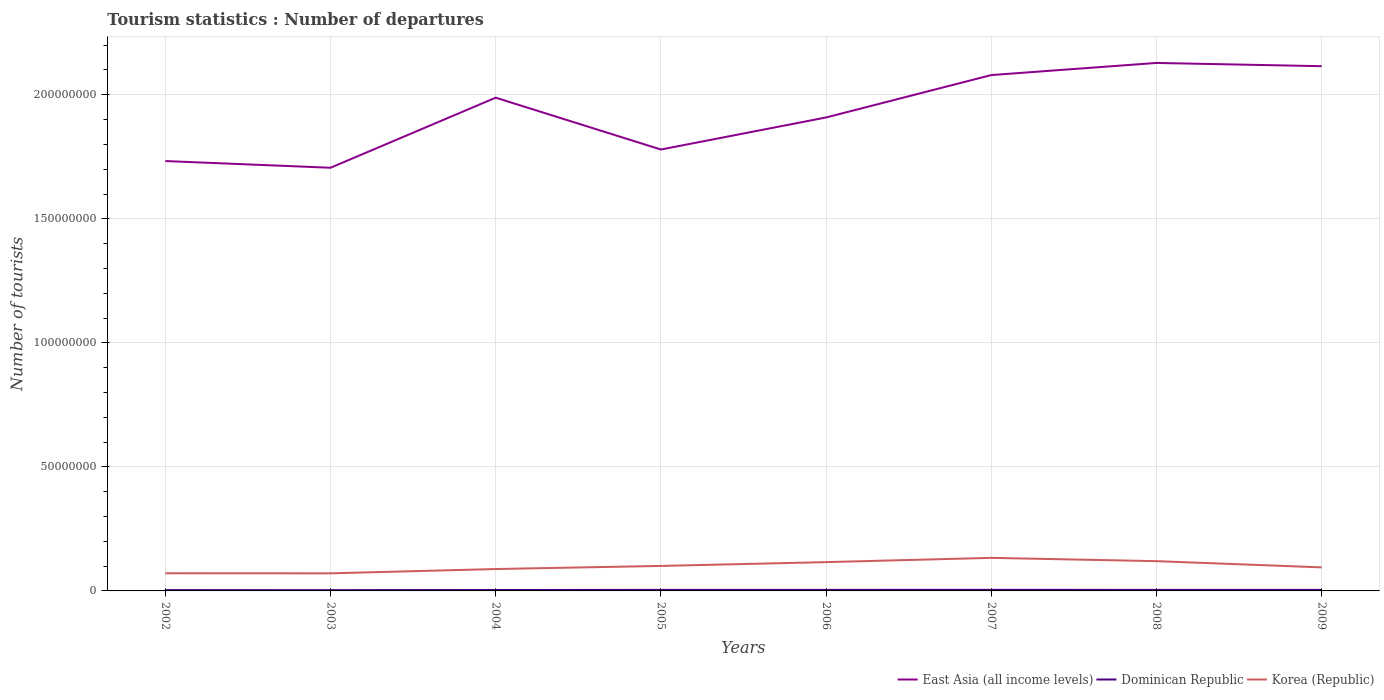Does the line corresponding to Dominican Republic intersect with the line corresponding to East Asia (all income levels)?
Offer a terse response. No. Is the number of lines equal to the number of legend labels?
Your answer should be compact. Yes. Across all years, what is the maximum number of tourist departures in Dominican Republic?
Offer a terse response. 3.21e+05. What is the total number of tourist departures in Dominican Republic in the graph?
Offer a very short reply. 2.80e+04. What is the difference between the highest and the second highest number of tourist departures in East Asia (all income levels)?
Provide a succinct answer. 4.23e+07. What is the difference between the highest and the lowest number of tourist departures in East Asia (all income levels)?
Offer a very short reply. 4. Is the number of tourist departures in East Asia (all income levels) strictly greater than the number of tourist departures in Dominican Republic over the years?
Give a very brief answer. No. How many lines are there?
Offer a terse response. 3. What is the difference between two consecutive major ticks on the Y-axis?
Your answer should be compact. 5.00e+07. Does the graph contain any zero values?
Keep it short and to the point. No. What is the title of the graph?
Offer a terse response. Tourism statistics : Number of departures. What is the label or title of the X-axis?
Your response must be concise. Years. What is the label or title of the Y-axis?
Provide a short and direct response. Number of tourists. What is the Number of tourists of East Asia (all income levels) in 2002?
Make the answer very short. 1.73e+08. What is the Number of tourists in Dominican Republic in 2002?
Your answer should be compact. 3.32e+05. What is the Number of tourists in Korea (Republic) in 2002?
Keep it short and to the point. 7.12e+06. What is the Number of tourists of East Asia (all income levels) in 2003?
Make the answer very short. 1.71e+08. What is the Number of tourists of Dominican Republic in 2003?
Give a very brief answer. 3.21e+05. What is the Number of tourists in Korea (Republic) in 2003?
Your answer should be very brief. 7.09e+06. What is the Number of tourists of East Asia (all income levels) in 2004?
Give a very brief answer. 1.99e+08. What is the Number of tourists in Dominican Republic in 2004?
Provide a short and direct response. 3.68e+05. What is the Number of tourists in Korea (Republic) in 2004?
Keep it short and to the point. 8.83e+06. What is the Number of tourists in East Asia (all income levels) in 2005?
Your answer should be very brief. 1.78e+08. What is the Number of tourists of Dominican Republic in 2005?
Ensure brevity in your answer.  4.19e+05. What is the Number of tourists in Korea (Republic) in 2005?
Your answer should be compact. 1.01e+07. What is the Number of tourists of East Asia (all income levels) in 2006?
Your answer should be compact. 1.91e+08. What is the Number of tourists of Dominican Republic in 2006?
Provide a short and direct response. 4.20e+05. What is the Number of tourists of Korea (Republic) in 2006?
Provide a succinct answer. 1.16e+07. What is the Number of tourists in East Asia (all income levels) in 2007?
Your answer should be very brief. 2.08e+08. What is the Number of tourists in Dominican Republic in 2007?
Provide a short and direct response. 4.43e+05. What is the Number of tourists of Korea (Republic) in 2007?
Ensure brevity in your answer.  1.33e+07. What is the Number of tourists in East Asia (all income levels) in 2008?
Give a very brief answer. 2.13e+08. What is the Number of tourists in Dominican Republic in 2008?
Your answer should be very brief. 4.13e+05. What is the Number of tourists of Korea (Republic) in 2008?
Offer a very short reply. 1.20e+07. What is the Number of tourists of East Asia (all income levels) in 2009?
Offer a very short reply. 2.12e+08. What is the Number of tourists of Dominican Republic in 2009?
Give a very brief answer. 4.15e+05. What is the Number of tourists of Korea (Republic) in 2009?
Ensure brevity in your answer.  9.49e+06. Across all years, what is the maximum Number of tourists of East Asia (all income levels)?
Your answer should be very brief. 2.13e+08. Across all years, what is the maximum Number of tourists in Dominican Republic?
Keep it short and to the point. 4.43e+05. Across all years, what is the maximum Number of tourists in Korea (Republic)?
Your answer should be very brief. 1.33e+07. Across all years, what is the minimum Number of tourists of East Asia (all income levels)?
Offer a terse response. 1.71e+08. Across all years, what is the minimum Number of tourists in Dominican Republic?
Your response must be concise. 3.21e+05. Across all years, what is the minimum Number of tourists of Korea (Republic)?
Your answer should be very brief. 7.09e+06. What is the total Number of tourists in East Asia (all income levels) in the graph?
Keep it short and to the point. 1.54e+09. What is the total Number of tourists in Dominican Republic in the graph?
Offer a very short reply. 3.13e+06. What is the total Number of tourists in Korea (Republic) in the graph?
Give a very brief answer. 7.95e+07. What is the difference between the Number of tourists in East Asia (all income levels) in 2002 and that in 2003?
Offer a very short reply. 2.70e+06. What is the difference between the Number of tourists in Dominican Republic in 2002 and that in 2003?
Your response must be concise. 1.10e+04. What is the difference between the Number of tourists in Korea (Republic) in 2002 and that in 2003?
Offer a very short reply. 3.70e+04. What is the difference between the Number of tourists of East Asia (all income levels) in 2002 and that in 2004?
Provide a short and direct response. -2.56e+07. What is the difference between the Number of tourists of Dominican Republic in 2002 and that in 2004?
Offer a very short reply. -3.60e+04. What is the difference between the Number of tourists of Korea (Republic) in 2002 and that in 2004?
Your answer should be compact. -1.70e+06. What is the difference between the Number of tourists of East Asia (all income levels) in 2002 and that in 2005?
Give a very brief answer. -4.65e+06. What is the difference between the Number of tourists in Dominican Republic in 2002 and that in 2005?
Ensure brevity in your answer.  -8.70e+04. What is the difference between the Number of tourists of Korea (Republic) in 2002 and that in 2005?
Keep it short and to the point. -2.96e+06. What is the difference between the Number of tourists in East Asia (all income levels) in 2002 and that in 2006?
Give a very brief answer. -1.76e+07. What is the difference between the Number of tourists of Dominican Republic in 2002 and that in 2006?
Offer a terse response. -8.80e+04. What is the difference between the Number of tourists in Korea (Republic) in 2002 and that in 2006?
Your response must be concise. -4.49e+06. What is the difference between the Number of tourists in East Asia (all income levels) in 2002 and that in 2007?
Provide a succinct answer. -3.47e+07. What is the difference between the Number of tourists in Dominican Republic in 2002 and that in 2007?
Provide a short and direct response. -1.11e+05. What is the difference between the Number of tourists in Korea (Republic) in 2002 and that in 2007?
Your answer should be very brief. -6.20e+06. What is the difference between the Number of tourists in East Asia (all income levels) in 2002 and that in 2008?
Provide a succinct answer. -3.96e+07. What is the difference between the Number of tourists of Dominican Republic in 2002 and that in 2008?
Keep it short and to the point. -8.10e+04. What is the difference between the Number of tourists in Korea (Republic) in 2002 and that in 2008?
Your answer should be compact. -4.87e+06. What is the difference between the Number of tourists of East Asia (all income levels) in 2002 and that in 2009?
Your response must be concise. -3.82e+07. What is the difference between the Number of tourists of Dominican Republic in 2002 and that in 2009?
Keep it short and to the point. -8.30e+04. What is the difference between the Number of tourists in Korea (Republic) in 2002 and that in 2009?
Make the answer very short. -2.37e+06. What is the difference between the Number of tourists of East Asia (all income levels) in 2003 and that in 2004?
Provide a short and direct response. -2.82e+07. What is the difference between the Number of tourists in Dominican Republic in 2003 and that in 2004?
Give a very brief answer. -4.70e+04. What is the difference between the Number of tourists in Korea (Republic) in 2003 and that in 2004?
Your answer should be very brief. -1.74e+06. What is the difference between the Number of tourists in East Asia (all income levels) in 2003 and that in 2005?
Your answer should be compact. -7.35e+06. What is the difference between the Number of tourists in Dominican Republic in 2003 and that in 2005?
Keep it short and to the point. -9.80e+04. What is the difference between the Number of tourists of Korea (Republic) in 2003 and that in 2005?
Offer a very short reply. -2.99e+06. What is the difference between the Number of tourists in East Asia (all income levels) in 2003 and that in 2006?
Offer a very short reply. -2.03e+07. What is the difference between the Number of tourists of Dominican Republic in 2003 and that in 2006?
Give a very brief answer. -9.90e+04. What is the difference between the Number of tourists in Korea (Republic) in 2003 and that in 2006?
Keep it short and to the point. -4.52e+06. What is the difference between the Number of tourists of East Asia (all income levels) in 2003 and that in 2007?
Your answer should be very brief. -3.74e+07. What is the difference between the Number of tourists in Dominican Republic in 2003 and that in 2007?
Your answer should be compact. -1.22e+05. What is the difference between the Number of tourists in Korea (Republic) in 2003 and that in 2007?
Your answer should be very brief. -6.24e+06. What is the difference between the Number of tourists of East Asia (all income levels) in 2003 and that in 2008?
Your answer should be very brief. -4.23e+07. What is the difference between the Number of tourists of Dominican Republic in 2003 and that in 2008?
Give a very brief answer. -9.20e+04. What is the difference between the Number of tourists in Korea (Republic) in 2003 and that in 2008?
Your response must be concise. -4.91e+06. What is the difference between the Number of tourists in East Asia (all income levels) in 2003 and that in 2009?
Offer a terse response. -4.09e+07. What is the difference between the Number of tourists of Dominican Republic in 2003 and that in 2009?
Your answer should be compact. -9.40e+04. What is the difference between the Number of tourists in Korea (Republic) in 2003 and that in 2009?
Keep it short and to the point. -2.41e+06. What is the difference between the Number of tourists of East Asia (all income levels) in 2004 and that in 2005?
Make the answer very short. 2.09e+07. What is the difference between the Number of tourists of Dominican Republic in 2004 and that in 2005?
Make the answer very short. -5.10e+04. What is the difference between the Number of tourists in Korea (Republic) in 2004 and that in 2005?
Provide a short and direct response. -1.25e+06. What is the difference between the Number of tourists in East Asia (all income levels) in 2004 and that in 2006?
Your answer should be very brief. 7.97e+06. What is the difference between the Number of tourists in Dominican Republic in 2004 and that in 2006?
Offer a terse response. -5.20e+04. What is the difference between the Number of tourists of Korea (Republic) in 2004 and that in 2006?
Provide a succinct answer. -2.78e+06. What is the difference between the Number of tourists of East Asia (all income levels) in 2004 and that in 2007?
Offer a very short reply. -9.12e+06. What is the difference between the Number of tourists of Dominican Republic in 2004 and that in 2007?
Your answer should be very brief. -7.50e+04. What is the difference between the Number of tourists of Korea (Republic) in 2004 and that in 2007?
Make the answer very short. -4.50e+06. What is the difference between the Number of tourists of East Asia (all income levels) in 2004 and that in 2008?
Your response must be concise. -1.40e+07. What is the difference between the Number of tourists in Dominican Republic in 2004 and that in 2008?
Make the answer very short. -4.50e+04. What is the difference between the Number of tourists of Korea (Republic) in 2004 and that in 2008?
Your response must be concise. -3.17e+06. What is the difference between the Number of tourists in East Asia (all income levels) in 2004 and that in 2009?
Provide a succinct answer. -1.27e+07. What is the difference between the Number of tourists of Dominican Republic in 2004 and that in 2009?
Ensure brevity in your answer.  -4.70e+04. What is the difference between the Number of tourists in Korea (Republic) in 2004 and that in 2009?
Make the answer very short. -6.68e+05. What is the difference between the Number of tourists of East Asia (all income levels) in 2005 and that in 2006?
Give a very brief answer. -1.29e+07. What is the difference between the Number of tourists in Dominican Republic in 2005 and that in 2006?
Your answer should be compact. -1000. What is the difference between the Number of tourists of Korea (Republic) in 2005 and that in 2006?
Make the answer very short. -1.53e+06. What is the difference between the Number of tourists of East Asia (all income levels) in 2005 and that in 2007?
Provide a succinct answer. -3.00e+07. What is the difference between the Number of tourists in Dominican Republic in 2005 and that in 2007?
Your answer should be very brief. -2.40e+04. What is the difference between the Number of tourists in Korea (Republic) in 2005 and that in 2007?
Your response must be concise. -3.24e+06. What is the difference between the Number of tourists of East Asia (all income levels) in 2005 and that in 2008?
Your response must be concise. -3.49e+07. What is the difference between the Number of tourists in Dominican Republic in 2005 and that in 2008?
Give a very brief answer. 6000. What is the difference between the Number of tourists of Korea (Republic) in 2005 and that in 2008?
Make the answer very short. -1.92e+06. What is the difference between the Number of tourists in East Asia (all income levels) in 2005 and that in 2009?
Provide a succinct answer. -3.36e+07. What is the difference between the Number of tourists of Dominican Republic in 2005 and that in 2009?
Your answer should be very brief. 4000. What is the difference between the Number of tourists of Korea (Republic) in 2005 and that in 2009?
Provide a short and direct response. 5.86e+05. What is the difference between the Number of tourists of East Asia (all income levels) in 2006 and that in 2007?
Ensure brevity in your answer.  -1.71e+07. What is the difference between the Number of tourists in Dominican Republic in 2006 and that in 2007?
Your answer should be very brief. -2.30e+04. What is the difference between the Number of tourists of Korea (Republic) in 2006 and that in 2007?
Offer a very short reply. -1.72e+06. What is the difference between the Number of tourists of East Asia (all income levels) in 2006 and that in 2008?
Ensure brevity in your answer.  -2.20e+07. What is the difference between the Number of tourists of Dominican Republic in 2006 and that in 2008?
Make the answer very short. 7000. What is the difference between the Number of tourists of Korea (Republic) in 2006 and that in 2008?
Offer a very short reply. -3.86e+05. What is the difference between the Number of tourists in East Asia (all income levels) in 2006 and that in 2009?
Your answer should be very brief. -2.07e+07. What is the difference between the Number of tourists in Dominican Republic in 2006 and that in 2009?
Keep it short and to the point. 5000. What is the difference between the Number of tourists in Korea (Republic) in 2006 and that in 2009?
Your response must be concise. 2.12e+06. What is the difference between the Number of tourists in East Asia (all income levels) in 2007 and that in 2008?
Make the answer very short. -4.89e+06. What is the difference between the Number of tourists in Dominican Republic in 2007 and that in 2008?
Keep it short and to the point. 3.00e+04. What is the difference between the Number of tourists of Korea (Republic) in 2007 and that in 2008?
Keep it short and to the point. 1.33e+06. What is the difference between the Number of tourists of East Asia (all income levels) in 2007 and that in 2009?
Provide a succinct answer. -3.58e+06. What is the difference between the Number of tourists in Dominican Republic in 2007 and that in 2009?
Offer a very short reply. 2.80e+04. What is the difference between the Number of tourists in Korea (Republic) in 2007 and that in 2009?
Give a very brief answer. 3.83e+06. What is the difference between the Number of tourists in East Asia (all income levels) in 2008 and that in 2009?
Provide a succinct answer. 1.31e+06. What is the difference between the Number of tourists of Dominican Republic in 2008 and that in 2009?
Provide a short and direct response. -2000. What is the difference between the Number of tourists of Korea (Republic) in 2008 and that in 2009?
Ensure brevity in your answer.  2.50e+06. What is the difference between the Number of tourists of East Asia (all income levels) in 2002 and the Number of tourists of Dominican Republic in 2003?
Ensure brevity in your answer.  1.73e+08. What is the difference between the Number of tourists of East Asia (all income levels) in 2002 and the Number of tourists of Korea (Republic) in 2003?
Provide a succinct answer. 1.66e+08. What is the difference between the Number of tourists in Dominican Republic in 2002 and the Number of tourists in Korea (Republic) in 2003?
Provide a short and direct response. -6.75e+06. What is the difference between the Number of tourists of East Asia (all income levels) in 2002 and the Number of tourists of Dominican Republic in 2004?
Your answer should be compact. 1.73e+08. What is the difference between the Number of tourists in East Asia (all income levels) in 2002 and the Number of tourists in Korea (Republic) in 2004?
Give a very brief answer. 1.64e+08. What is the difference between the Number of tourists in Dominican Republic in 2002 and the Number of tourists in Korea (Republic) in 2004?
Your answer should be compact. -8.49e+06. What is the difference between the Number of tourists of East Asia (all income levels) in 2002 and the Number of tourists of Dominican Republic in 2005?
Your answer should be compact. 1.73e+08. What is the difference between the Number of tourists in East Asia (all income levels) in 2002 and the Number of tourists in Korea (Republic) in 2005?
Your answer should be very brief. 1.63e+08. What is the difference between the Number of tourists in Dominican Republic in 2002 and the Number of tourists in Korea (Republic) in 2005?
Your answer should be compact. -9.75e+06. What is the difference between the Number of tourists in East Asia (all income levels) in 2002 and the Number of tourists in Dominican Republic in 2006?
Keep it short and to the point. 1.73e+08. What is the difference between the Number of tourists of East Asia (all income levels) in 2002 and the Number of tourists of Korea (Republic) in 2006?
Your answer should be very brief. 1.62e+08. What is the difference between the Number of tourists in Dominican Republic in 2002 and the Number of tourists in Korea (Republic) in 2006?
Make the answer very short. -1.13e+07. What is the difference between the Number of tourists in East Asia (all income levels) in 2002 and the Number of tourists in Dominican Republic in 2007?
Ensure brevity in your answer.  1.73e+08. What is the difference between the Number of tourists of East Asia (all income levels) in 2002 and the Number of tourists of Korea (Republic) in 2007?
Your response must be concise. 1.60e+08. What is the difference between the Number of tourists in Dominican Republic in 2002 and the Number of tourists in Korea (Republic) in 2007?
Make the answer very short. -1.30e+07. What is the difference between the Number of tourists in East Asia (all income levels) in 2002 and the Number of tourists in Dominican Republic in 2008?
Your answer should be very brief. 1.73e+08. What is the difference between the Number of tourists of East Asia (all income levels) in 2002 and the Number of tourists of Korea (Republic) in 2008?
Keep it short and to the point. 1.61e+08. What is the difference between the Number of tourists of Dominican Republic in 2002 and the Number of tourists of Korea (Republic) in 2008?
Offer a terse response. -1.17e+07. What is the difference between the Number of tourists of East Asia (all income levels) in 2002 and the Number of tourists of Dominican Republic in 2009?
Keep it short and to the point. 1.73e+08. What is the difference between the Number of tourists of East Asia (all income levels) in 2002 and the Number of tourists of Korea (Republic) in 2009?
Provide a short and direct response. 1.64e+08. What is the difference between the Number of tourists in Dominican Republic in 2002 and the Number of tourists in Korea (Republic) in 2009?
Provide a succinct answer. -9.16e+06. What is the difference between the Number of tourists of East Asia (all income levels) in 2003 and the Number of tourists of Dominican Republic in 2004?
Provide a succinct answer. 1.70e+08. What is the difference between the Number of tourists in East Asia (all income levels) in 2003 and the Number of tourists in Korea (Republic) in 2004?
Provide a short and direct response. 1.62e+08. What is the difference between the Number of tourists in Dominican Republic in 2003 and the Number of tourists in Korea (Republic) in 2004?
Make the answer very short. -8.50e+06. What is the difference between the Number of tourists in East Asia (all income levels) in 2003 and the Number of tourists in Dominican Republic in 2005?
Provide a succinct answer. 1.70e+08. What is the difference between the Number of tourists in East Asia (all income levels) in 2003 and the Number of tourists in Korea (Republic) in 2005?
Give a very brief answer. 1.61e+08. What is the difference between the Number of tourists in Dominican Republic in 2003 and the Number of tourists in Korea (Republic) in 2005?
Offer a very short reply. -9.76e+06. What is the difference between the Number of tourists of East Asia (all income levels) in 2003 and the Number of tourists of Dominican Republic in 2006?
Give a very brief answer. 1.70e+08. What is the difference between the Number of tourists of East Asia (all income levels) in 2003 and the Number of tourists of Korea (Republic) in 2006?
Ensure brevity in your answer.  1.59e+08. What is the difference between the Number of tourists of Dominican Republic in 2003 and the Number of tourists of Korea (Republic) in 2006?
Offer a very short reply. -1.13e+07. What is the difference between the Number of tourists in East Asia (all income levels) in 2003 and the Number of tourists in Dominican Republic in 2007?
Your answer should be compact. 1.70e+08. What is the difference between the Number of tourists in East Asia (all income levels) in 2003 and the Number of tourists in Korea (Republic) in 2007?
Your response must be concise. 1.57e+08. What is the difference between the Number of tourists of Dominican Republic in 2003 and the Number of tourists of Korea (Republic) in 2007?
Offer a very short reply. -1.30e+07. What is the difference between the Number of tourists of East Asia (all income levels) in 2003 and the Number of tourists of Dominican Republic in 2008?
Keep it short and to the point. 1.70e+08. What is the difference between the Number of tourists in East Asia (all income levels) in 2003 and the Number of tourists in Korea (Republic) in 2008?
Make the answer very short. 1.59e+08. What is the difference between the Number of tourists in Dominican Republic in 2003 and the Number of tourists in Korea (Republic) in 2008?
Give a very brief answer. -1.17e+07. What is the difference between the Number of tourists of East Asia (all income levels) in 2003 and the Number of tourists of Dominican Republic in 2009?
Ensure brevity in your answer.  1.70e+08. What is the difference between the Number of tourists of East Asia (all income levels) in 2003 and the Number of tourists of Korea (Republic) in 2009?
Your answer should be very brief. 1.61e+08. What is the difference between the Number of tourists of Dominican Republic in 2003 and the Number of tourists of Korea (Republic) in 2009?
Give a very brief answer. -9.17e+06. What is the difference between the Number of tourists of East Asia (all income levels) in 2004 and the Number of tourists of Dominican Republic in 2005?
Keep it short and to the point. 1.98e+08. What is the difference between the Number of tourists in East Asia (all income levels) in 2004 and the Number of tourists in Korea (Republic) in 2005?
Your answer should be very brief. 1.89e+08. What is the difference between the Number of tourists in Dominican Republic in 2004 and the Number of tourists in Korea (Republic) in 2005?
Your answer should be compact. -9.71e+06. What is the difference between the Number of tourists of East Asia (all income levels) in 2004 and the Number of tourists of Dominican Republic in 2006?
Your answer should be compact. 1.98e+08. What is the difference between the Number of tourists in East Asia (all income levels) in 2004 and the Number of tourists in Korea (Republic) in 2006?
Give a very brief answer. 1.87e+08. What is the difference between the Number of tourists in Dominican Republic in 2004 and the Number of tourists in Korea (Republic) in 2006?
Your answer should be compact. -1.12e+07. What is the difference between the Number of tourists in East Asia (all income levels) in 2004 and the Number of tourists in Dominican Republic in 2007?
Provide a short and direct response. 1.98e+08. What is the difference between the Number of tourists in East Asia (all income levels) in 2004 and the Number of tourists in Korea (Republic) in 2007?
Offer a very short reply. 1.86e+08. What is the difference between the Number of tourists in Dominican Republic in 2004 and the Number of tourists in Korea (Republic) in 2007?
Offer a terse response. -1.30e+07. What is the difference between the Number of tourists in East Asia (all income levels) in 2004 and the Number of tourists in Dominican Republic in 2008?
Your answer should be very brief. 1.98e+08. What is the difference between the Number of tourists of East Asia (all income levels) in 2004 and the Number of tourists of Korea (Republic) in 2008?
Your response must be concise. 1.87e+08. What is the difference between the Number of tourists in Dominican Republic in 2004 and the Number of tourists in Korea (Republic) in 2008?
Make the answer very short. -1.16e+07. What is the difference between the Number of tourists of East Asia (all income levels) in 2004 and the Number of tourists of Dominican Republic in 2009?
Your answer should be very brief. 1.98e+08. What is the difference between the Number of tourists of East Asia (all income levels) in 2004 and the Number of tourists of Korea (Republic) in 2009?
Keep it short and to the point. 1.89e+08. What is the difference between the Number of tourists in Dominican Republic in 2004 and the Number of tourists in Korea (Republic) in 2009?
Your response must be concise. -9.13e+06. What is the difference between the Number of tourists in East Asia (all income levels) in 2005 and the Number of tourists in Dominican Republic in 2006?
Ensure brevity in your answer.  1.78e+08. What is the difference between the Number of tourists of East Asia (all income levels) in 2005 and the Number of tourists of Korea (Republic) in 2006?
Give a very brief answer. 1.66e+08. What is the difference between the Number of tourists in Dominican Republic in 2005 and the Number of tourists in Korea (Republic) in 2006?
Keep it short and to the point. -1.12e+07. What is the difference between the Number of tourists in East Asia (all income levels) in 2005 and the Number of tourists in Dominican Republic in 2007?
Offer a very short reply. 1.77e+08. What is the difference between the Number of tourists in East Asia (all income levels) in 2005 and the Number of tourists in Korea (Republic) in 2007?
Your answer should be compact. 1.65e+08. What is the difference between the Number of tourists of Dominican Republic in 2005 and the Number of tourists of Korea (Republic) in 2007?
Your response must be concise. -1.29e+07. What is the difference between the Number of tourists of East Asia (all income levels) in 2005 and the Number of tourists of Dominican Republic in 2008?
Offer a terse response. 1.78e+08. What is the difference between the Number of tourists in East Asia (all income levels) in 2005 and the Number of tourists in Korea (Republic) in 2008?
Provide a short and direct response. 1.66e+08. What is the difference between the Number of tourists of Dominican Republic in 2005 and the Number of tourists of Korea (Republic) in 2008?
Offer a very short reply. -1.16e+07. What is the difference between the Number of tourists in East Asia (all income levels) in 2005 and the Number of tourists in Dominican Republic in 2009?
Ensure brevity in your answer.  1.78e+08. What is the difference between the Number of tourists of East Asia (all income levels) in 2005 and the Number of tourists of Korea (Republic) in 2009?
Offer a very short reply. 1.68e+08. What is the difference between the Number of tourists of Dominican Republic in 2005 and the Number of tourists of Korea (Republic) in 2009?
Make the answer very short. -9.08e+06. What is the difference between the Number of tourists in East Asia (all income levels) in 2006 and the Number of tourists in Dominican Republic in 2007?
Your answer should be very brief. 1.90e+08. What is the difference between the Number of tourists of East Asia (all income levels) in 2006 and the Number of tourists of Korea (Republic) in 2007?
Keep it short and to the point. 1.78e+08. What is the difference between the Number of tourists in Dominican Republic in 2006 and the Number of tourists in Korea (Republic) in 2007?
Offer a very short reply. -1.29e+07. What is the difference between the Number of tourists of East Asia (all income levels) in 2006 and the Number of tourists of Dominican Republic in 2008?
Your response must be concise. 1.90e+08. What is the difference between the Number of tourists in East Asia (all income levels) in 2006 and the Number of tourists in Korea (Republic) in 2008?
Provide a succinct answer. 1.79e+08. What is the difference between the Number of tourists of Dominican Republic in 2006 and the Number of tourists of Korea (Republic) in 2008?
Your answer should be compact. -1.16e+07. What is the difference between the Number of tourists of East Asia (all income levels) in 2006 and the Number of tourists of Dominican Republic in 2009?
Make the answer very short. 1.90e+08. What is the difference between the Number of tourists of East Asia (all income levels) in 2006 and the Number of tourists of Korea (Republic) in 2009?
Your answer should be compact. 1.81e+08. What is the difference between the Number of tourists in Dominican Republic in 2006 and the Number of tourists in Korea (Republic) in 2009?
Give a very brief answer. -9.07e+06. What is the difference between the Number of tourists in East Asia (all income levels) in 2007 and the Number of tourists in Dominican Republic in 2008?
Offer a terse response. 2.08e+08. What is the difference between the Number of tourists of East Asia (all income levels) in 2007 and the Number of tourists of Korea (Republic) in 2008?
Ensure brevity in your answer.  1.96e+08. What is the difference between the Number of tourists in Dominican Republic in 2007 and the Number of tourists in Korea (Republic) in 2008?
Your answer should be compact. -1.16e+07. What is the difference between the Number of tourists of East Asia (all income levels) in 2007 and the Number of tourists of Dominican Republic in 2009?
Give a very brief answer. 2.08e+08. What is the difference between the Number of tourists of East Asia (all income levels) in 2007 and the Number of tourists of Korea (Republic) in 2009?
Ensure brevity in your answer.  1.98e+08. What is the difference between the Number of tourists in Dominican Republic in 2007 and the Number of tourists in Korea (Republic) in 2009?
Offer a very short reply. -9.05e+06. What is the difference between the Number of tourists of East Asia (all income levels) in 2008 and the Number of tourists of Dominican Republic in 2009?
Your response must be concise. 2.12e+08. What is the difference between the Number of tourists in East Asia (all income levels) in 2008 and the Number of tourists in Korea (Republic) in 2009?
Keep it short and to the point. 2.03e+08. What is the difference between the Number of tourists of Dominican Republic in 2008 and the Number of tourists of Korea (Republic) in 2009?
Keep it short and to the point. -9.08e+06. What is the average Number of tourists in East Asia (all income levels) per year?
Offer a very short reply. 1.93e+08. What is the average Number of tourists of Dominican Republic per year?
Your answer should be compact. 3.91e+05. What is the average Number of tourists of Korea (Republic) per year?
Ensure brevity in your answer.  9.94e+06. In the year 2002, what is the difference between the Number of tourists in East Asia (all income levels) and Number of tourists in Dominican Republic?
Give a very brief answer. 1.73e+08. In the year 2002, what is the difference between the Number of tourists in East Asia (all income levels) and Number of tourists in Korea (Republic)?
Make the answer very short. 1.66e+08. In the year 2002, what is the difference between the Number of tourists of Dominican Republic and Number of tourists of Korea (Republic)?
Your answer should be compact. -6.79e+06. In the year 2003, what is the difference between the Number of tourists of East Asia (all income levels) and Number of tourists of Dominican Republic?
Provide a short and direct response. 1.70e+08. In the year 2003, what is the difference between the Number of tourists of East Asia (all income levels) and Number of tourists of Korea (Republic)?
Offer a very short reply. 1.63e+08. In the year 2003, what is the difference between the Number of tourists of Dominican Republic and Number of tourists of Korea (Republic)?
Make the answer very short. -6.76e+06. In the year 2004, what is the difference between the Number of tourists of East Asia (all income levels) and Number of tourists of Dominican Republic?
Offer a very short reply. 1.98e+08. In the year 2004, what is the difference between the Number of tourists of East Asia (all income levels) and Number of tourists of Korea (Republic)?
Provide a succinct answer. 1.90e+08. In the year 2004, what is the difference between the Number of tourists in Dominican Republic and Number of tourists in Korea (Republic)?
Your answer should be very brief. -8.46e+06. In the year 2005, what is the difference between the Number of tourists of East Asia (all income levels) and Number of tourists of Dominican Republic?
Ensure brevity in your answer.  1.78e+08. In the year 2005, what is the difference between the Number of tourists in East Asia (all income levels) and Number of tourists in Korea (Republic)?
Keep it short and to the point. 1.68e+08. In the year 2005, what is the difference between the Number of tourists of Dominican Republic and Number of tourists of Korea (Republic)?
Provide a short and direct response. -9.66e+06. In the year 2006, what is the difference between the Number of tourists in East Asia (all income levels) and Number of tourists in Dominican Republic?
Give a very brief answer. 1.90e+08. In the year 2006, what is the difference between the Number of tourists in East Asia (all income levels) and Number of tourists in Korea (Republic)?
Give a very brief answer. 1.79e+08. In the year 2006, what is the difference between the Number of tourists in Dominican Republic and Number of tourists in Korea (Republic)?
Make the answer very short. -1.12e+07. In the year 2007, what is the difference between the Number of tourists of East Asia (all income levels) and Number of tourists of Dominican Republic?
Make the answer very short. 2.08e+08. In the year 2007, what is the difference between the Number of tourists in East Asia (all income levels) and Number of tourists in Korea (Republic)?
Your answer should be very brief. 1.95e+08. In the year 2007, what is the difference between the Number of tourists in Dominican Republic and Number of tourists in Korea (Republic)?
Make the answer very short. -1.29e+07. In the year 2008, what is the difference between the Number of tourists in East Asia (all income levels) and Number of tourists in Dominican Republic?
Offer a very short reply. 2.12e+08. In the year 2008, what is the difference between the Number of tourists in East Asia (all income levels) and Number of tourists in Korea (Republic)?
Provide a short and direct response. 2.01e+08. In the year 2008, what is the difference between the Number of tourists in Dominican Republic and Number of tourists in Korea (Republic)?
Keep it short and to the point. -1.16e+07. In the year 2009, what is the difference between the Number of tourists of East Asia (all income levels) and Number of tourists of Dominican Republic?
Provide a succinct answer. 2.11e+08. In the year 2009, what is the difference between the Number of tourists of East Asia (all income levels) and Number of tourists of Korea (Republic)?
Your response must be concise. 2.02e+08. In the year 2009, what is the difference between the Number of tourists in Dominican Republic and Number of tourists in Korea (Republic)?
Give a very brief answer. -9.08e+06. What is the ratio of the Number of tourists of East Asia (all income levels) in 2002 to that in 2003?
Keep it short and to the point. 1.02. What is the ratio of the Number of tourists of Dominican Republic in 2002 to that in 2003?
Make the answer very short. 1.03. What is the ratio of the Number of tourists in Korea (Republic) in 2002 to that in 2003?
Provide a succinct answer. 1.01. What is the ratio of the Number of tourists of East Asia (all income levels) in 2002 to that in 2004?
Give a very brief answer. 0.87. What is the ratio of the Number of tourists of Dominican Republic in 2002 to that in 2004?
Your answer should be very brief. 0.9. What is the ratio of the Number of tourists of Korea (Republic) in 2002 to that in 2004?
Provide a succinct answer. 0.81. What is the ratio of the Number of tourists in East Asia (all income levels) in 2002 to that in 2005?
Provide a short and direct response. 0.97. What is the ratio of the Number of tourists in Dominican Republic in 2002 to that in 2005?
Make the answer very short. 0.79. What is the ratio of the Number of tourists of Korea (Republic) in 2002 to that in 2005?
Provide a short and direct response. 0.71. What is the ratio of the Number of tourists in East Asia (all income levels) in 2002 to that in 2006?
Your answer should be very brief. 0.91. What is the ratio of the Number of tourists of Dominican Republic in 2002 to that in 2006?
Offer a very short reply. 0.79. What is the ratio of the Number of tourists of Korea (Republic) in 2002 to that in 2006?
Offer a terse response. 0.61. What is the ratio of the Number of tourists of Dominican Republic in 2002 to that in 2007?
Your response must be concise. 0.75. What is the ratio of the Number of tourists of Korea (Republic) in 2002 to that in 2007?
Make the answer very short. 0.53. What is the ratio of the Number of tourists of East Asia (all income levels) in 2002 to that in 2008?
Your response must be concise. 0.81. What is the ratio of the Number of tourists in Dominican Republic in 2002 to that in 2008?
Offer a very short reply. 0.8. What is the ratio of the Number of tourists in Korea (Republic) in 2002 to that in 2008?
Make the answer very short. 0.59. What is the ratio of the Number of tourists in East Asia (all income levels) in 2002 to that in 2009?
Your response must be concise. 0.82. What is the ratio of the Number of tourists in Korea (Republic) in 2002 to that in 2009?
Ensure brevity in your answer.  0.75. What is the ratio of the Number of tourists in East Asia (all income levels) in 2003 to that in 2004?
Provide a short and direct response. 0.86. What is the ratio of the Number of tourists of Dominican Republic in 2003 to that in 2004?
Your response must be concise. 0.87. What is the ratio of the Number of tourists of Korea (Republic) in 2003 to that in 2004?
Your response must be concise. 0.8. What is the ratio of the Number of tourists of East Asia (all income levels) in 2003 to that in 2005?
Give a very brief answer. 0.96. What is the ratio of the Number of tourists in Dominican Republic in 2003 to that in 2005?
Provide a short and direct response. 0.77. What is the ratio of the Number of tourists in Korea (Republic) in 2003 to that in 2005?
Offer a very short reply. 0.7. What is the ratio of the Number of tourists of East Asia (all income levels) in 2003 to that in 2006?
Provide a short and direct response. 0.89. What is the ratio of the Number of tourists of Dominican Republic in 2003 to that in 2006?
Your response must be concise. 0.76. What is the ratio of the Number of tourists in Korea (Republic) in 2003 to that in 2006?
Provide a short and direct response. 0.61. What is the ratio of the Number of tourists in East Asia (all income levels) in 2003 to that in 2007?
Your response must be concise. 0.82. What is the ratio of the Number of tourists of Dominican Republic in 2003 to that in 2007?
Your answer should be very brief. 0.72. What is the ratio of the Number of tourists in Korea (Republic) in 2003 to that in 2007?
Keep it short and to the point. 0.53. What is the ratio of the Number of tourists of East Asia (all income levels) in 2003 to that in 2008?
Keep it short and to the point. 0.8. What is the ratio of the Number of tourists in Dominican Republic in 2003 to that in 2008?
Keep it short and to the point. 0.78. What is the ratio of the Number of tourists of Korea (Republic) in 2003 to that in 2008?
Offer a terse response. 0.59. What is the ratio of the Number of tourists in East Asia (all income levels) in 2003 to that in 2009?
Keep it short and to the point. 0.81. What is the ratio of the Number of tourists in Dominican Republic in 2003 to that in 2009?
Your answer should be compact. 0.77. What is the ratio of the Number of tourists of Korea (Republic) in 2003 to that in 2009?
Provide a short and direct response. 0.75. What is the ratio of the Number of tourists in East Asia (all income levels) in 2004 to that in 2005?
Provide a short and direct response. 1.12. What is the ratio of the Number of tourists of Dominican Republic in 2004 to that in 2005?
Keep it short and to the point. 0.88. What is the ratio of the Number of tourists of Korea (Republic) in 2004 to that in 2005?
Your answer should be compact. 0.88. What is the ratio of the Number of tourists of East Asia (all income levels) in 2004 to that in 2006?
Provide a short and direct response. 1.04. What is the ratio of the Number of tourists in Dominican Republic in 2004 to that in 2006?
Ensure brevity in your answer.  0.88. What is the ratio of the Number of tourists in Korea (Republic) in 2004 to that in 2006?
Provide a succinct answer. 0.76. What is the ratio of the Number of tourists of East Asia (all income levels) in 2004 to that in 2007?
Your response must be concise. 0.96. What is the ratio of the Number of tourists in Dominican Republic in 2004 to that in 2007?
Make the answer very short. 0.83. What is the ratio of the Number of tourists of Korea (Republic) in 2004 to that in 2007?
Your response must be concise. 0.66. What is the ratio of the Number of tourists in East Asia (all income levels) in 2004 to that in 2008?
Ensure brevity in your answer.  0.93. What is the ratio of the Number of tourists in Dominican Republic in 2004 to that in 2008?
Provide a short and direct response. 0.89. What is the ratio of the Number of tourists in Korea (Republic) in 2004 to that in 2008?
Give a very brief answer. 0.74. What is the ratio of the Number of tourists in Dominican Republic in 2004 to that in 2009?
Your response must be concise. 0.89. What is the ratio of the Number of tourists of Korea (Republic) in 2004 to that in 2009?
Your response must be concise. 0.93. What is the ratio of the Number of tourists of East Asia (all income levels) in 2005 to that in 2006?
Give a very brief answer. 0.93. What is the ratio of the Number of tourists in Dominican Republic in 2005 to that in 2006?
Ensure brevity in your answer.  1. What is the ratio of the Number of tourists of Korea (Republic) in 2005 to that in 2006?
Give a very brief answer. 0.87. What is the ratio of the Number of tourists of East Asia (all income levels) in 2005 to that in 2007?
Give a very brief answer. 0.86. What is the ratio of the Number of tourists in Dominican Republic in 2005 to that in 2007?
Your response must be concise. 0.95. What is the ratio of the Number of tourists of Korea (Republic) in 2005 to that in 2007?
Offer a terse response. 0.76. What is the ratio of the Number of tourists in East Asia (all income levels) in 2005 to that in 2008?
Offer a very short reply. 0.84. What is the ratio of the Number of tourists in Dominican Republic in 2005 to that in 2008?
Provide a succinct answer. 1.01. What is the ratio of the Number of tourists of Korea (Republic) in 2005 to that in 2008?
Your answer should be compact. 0.84. What is the ratio of the Number of tourists in East Asia (all income levels) in 2005 to that in 2009?
Give a very brief answer. 0.84. What is the ratio of the Number of tourists in Dominican Republic in 2005 to that in 2009?
Your response must be concise. 1.01. What is the ratio of the Number of tourists of Korea (Republic) in 2005 to that in 2009?
Offer a very short reply. 1.06. What is the ratio of the Number of tourists in East Asia (all income levels) in 2006 to that in 2007?
Give a very brief answer. 0.92. What is the ratio of the Number of tourists in Dominican Republic in 2006 to that in 2007?
Give a very brief answer. 0.95. What is the ratio of the Number of tourists of Korea (Republic) in 2006 to that in 2007?
Your answer should be very brief. 0.87. What is the ratio of the Number of tourists in East Asia (all income levels) in 2006 to that in 2008?
Your answer should be very brief. 0.9. What is the ratio of the Number of tourists in Dominican Republic in 2006 to that in 2008?
Give a very brief answer. 1.02. What is the ratio of the Number of tourists in Korea (Republic) in 2006 to that in 2008?
Offer a very short reply. 0.97. What is the ratio of the Number of tourists of East Asia (all income levels) in 2006 to that in 2009?
Offer a very short reply. 0.9. What is the ratio of the Number of tourists in Dominican Republic in 2006 to that in 2009?
Ensure brevity in your answer.  1.01. What is the ratio of the Number of tourists of Korea (Republic) in 2006 to that in 2009?
Your response must be concise. 1.22. What is the ratio of the Number of tourists of Dominican Republic in 2007 to that in 2008?
Provide a short and direct response. 1.07. What is the ratio of the Number of tourists in Korea (Republic) in 2007 to that in 2008?
Your answer should be compact. 1.11. What is the ratio of the Number of tourists of East Asia (all income levels) in 2007 to that in 2009?
Offer a terse response. 0.98. What is the ratio of the Number of tourists of Dominican Republic in 2007 to that in 2009?
Your answer should be very brief. 1.07. What is the ratio of the Number of tourists in Korea (Republic) in 2007 to that in 2009?
Your response must be concise. 1.4. What is the ratio of the Number of tourists in Korea (Republic) in 2008 to that in 2009?
Make the answer very short. 1.26. What is the difference between the highest and the second highest Number of tourists of East Asia (all income levels)?
Offer a very short reply. 1.31e+06. What is the difference between the highest and the second highest Number of tourists in Dominican Republic?
Ensure brevity in your answer.  2.30e+04. What is the difference between the highest and the second highest Number of tourists of Korea (Republic)?
Offer a very short reply. 1.33e+06. What is the difference between the highest and the lowest Number of tourists of East Asia (all income levels)?
Provide a succinct answer. 4.23e+07. What is the difference between the highest and the lowest Number of tourists of Dominican Republic?
Your answer should be compact. 1.22e+05. What is the difference between the highest and the lowest Number of tourists in Korea (Republic)?
Provide a short and direct response. 6.24e+06. 